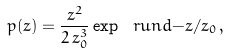Convert formula to latex. <formula><loc_0><loc_0><loc_500><loc_500>p ( z ) = \frac { z ^ { 2 } } { 2 \, z _ { 0 } ^ { 3 } } \exp \ r u n d { - z / z _ { 0 } } \, ,</formula> 